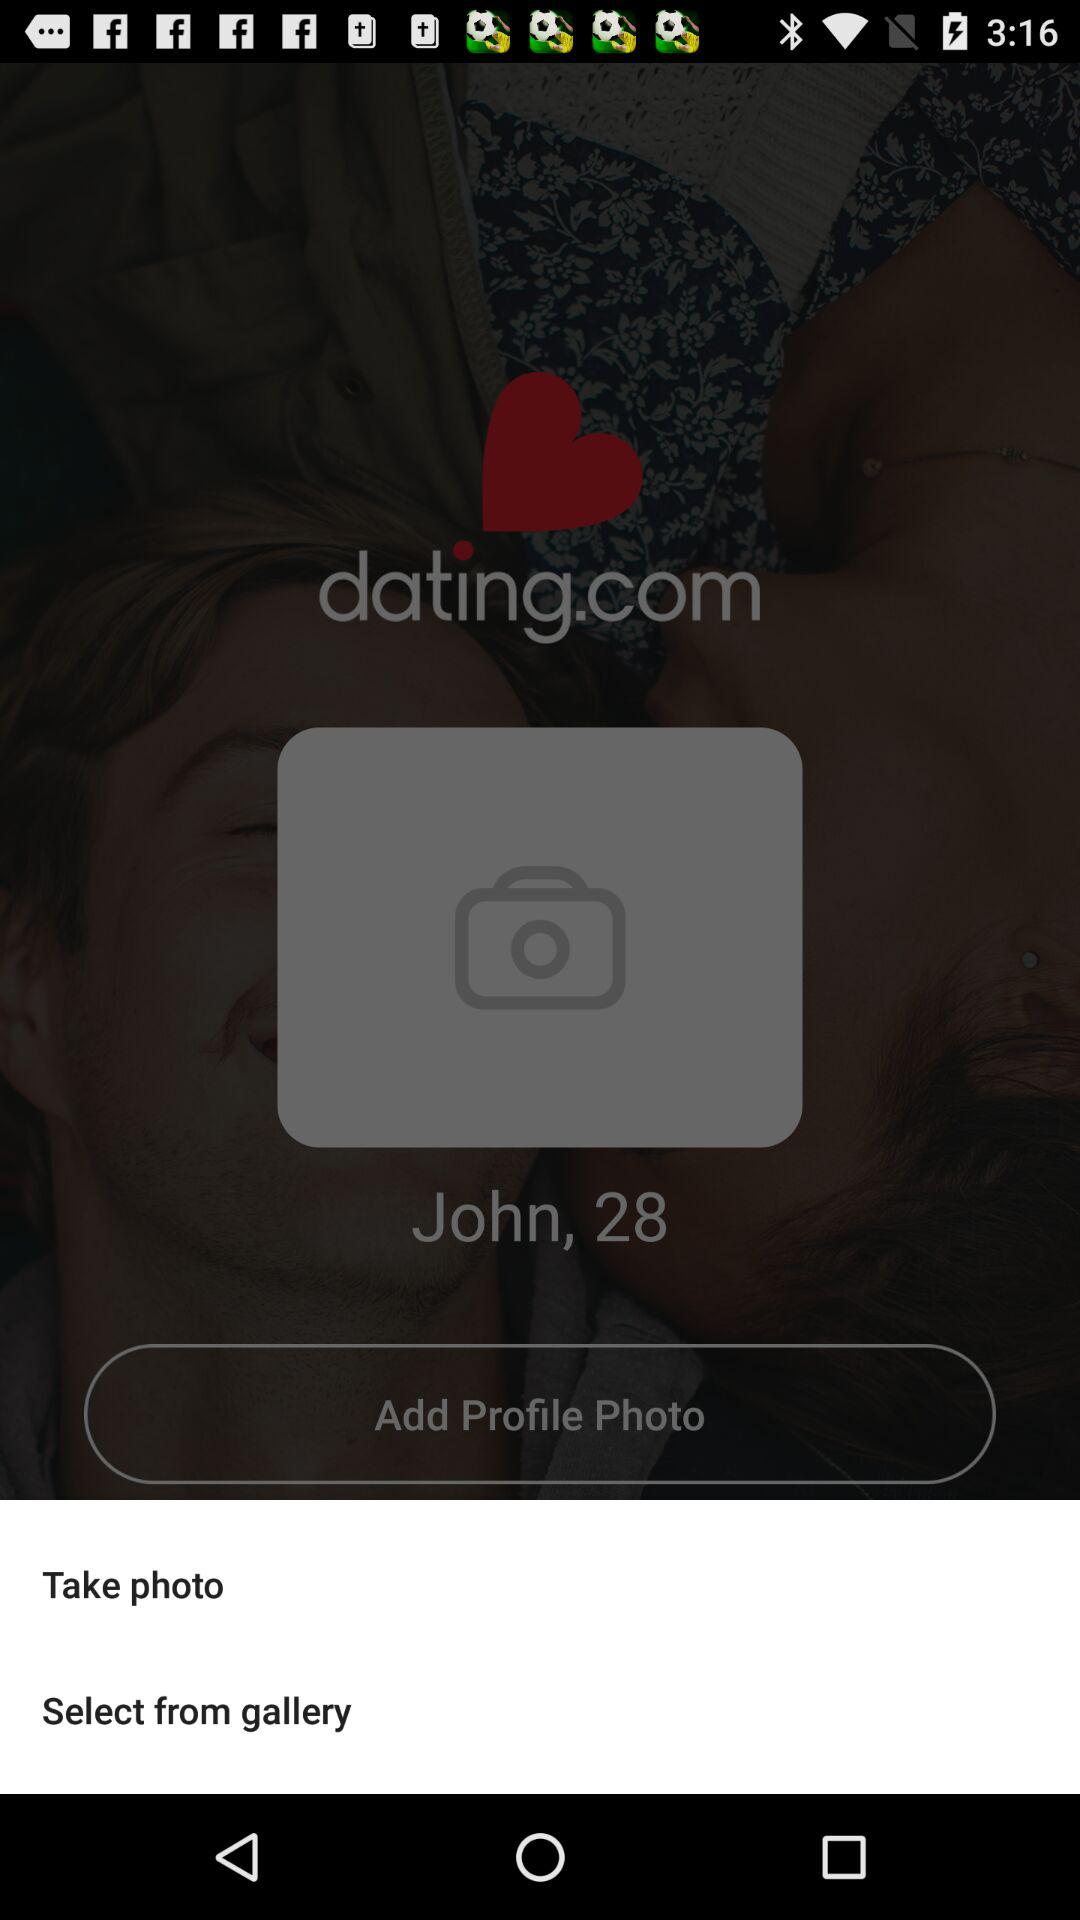What is the application name? The application name is "dating.com". 